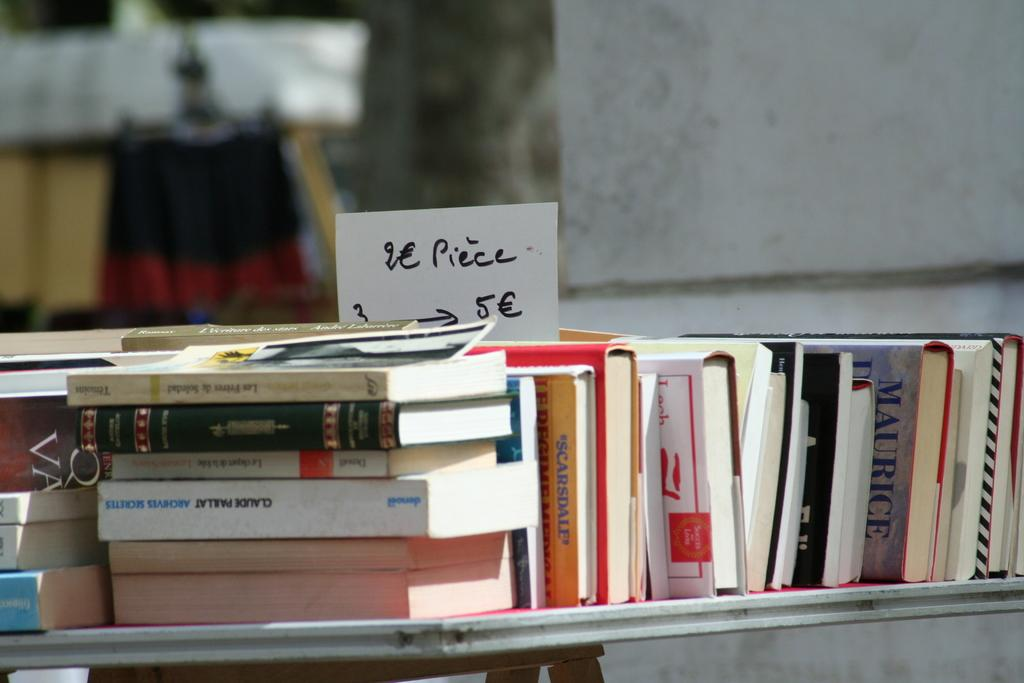What objects can be seen on the table in the image? There are many books on the table in the image. What else can be seen on the table besides the books? There is a white color paper with a price tag in the image. Can you describe the background of the image? The background of the image is blurred. What type of lunch is being served in the image? There is no lunch present in the image; it features books and a paper with a price tag on a table. What is the friction between the books and the table in the image? The provided facts do not mention friction, and it cannot be determined from the image. 